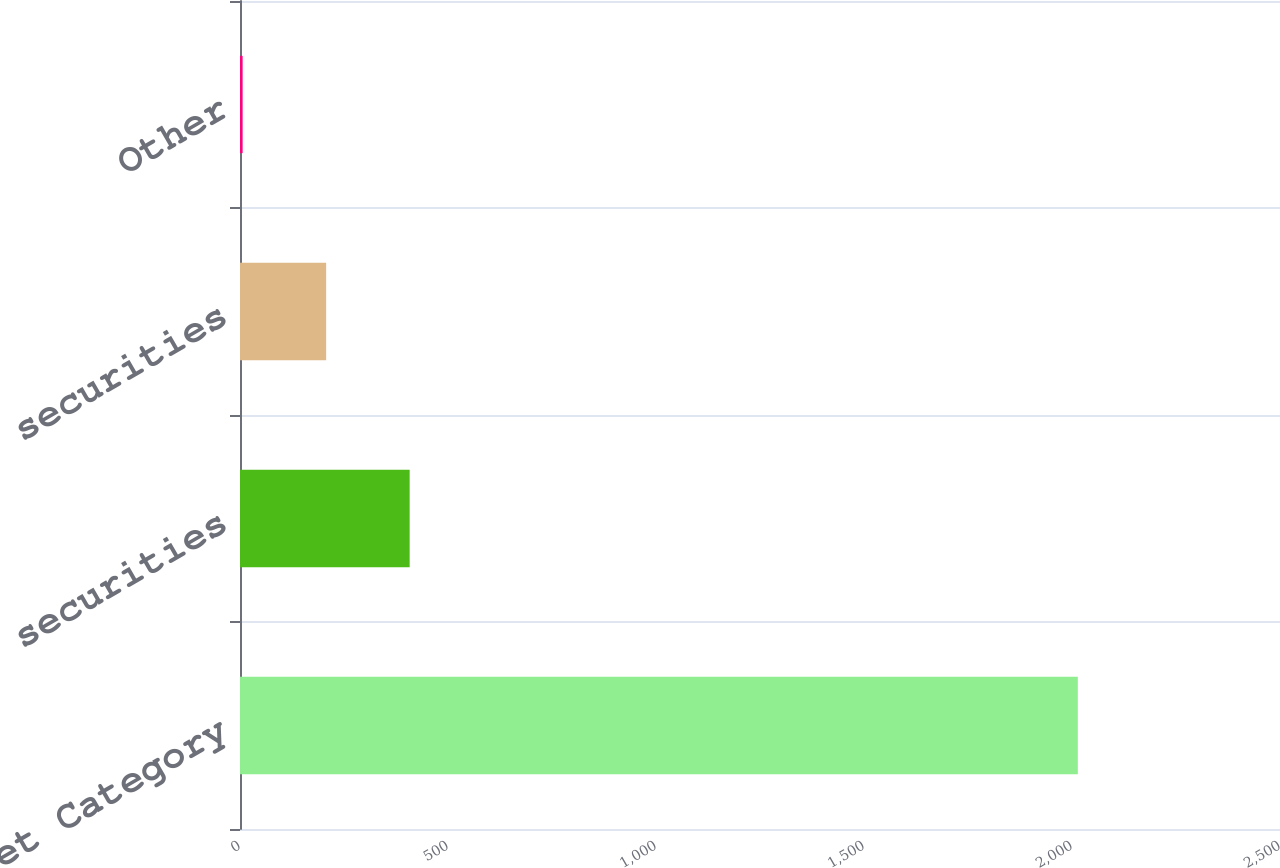Convert chart to OTSL. <chart><loc_0><loc_0><loc_500><loc_500><bar_chart><fcel>Asset Category<fcel>Equity securities<fcel>Debt securities<fcel>Other<nl><fcel>2014<fcel>407.84<fcel>207.07<fcel>6.3<nl></chart> 